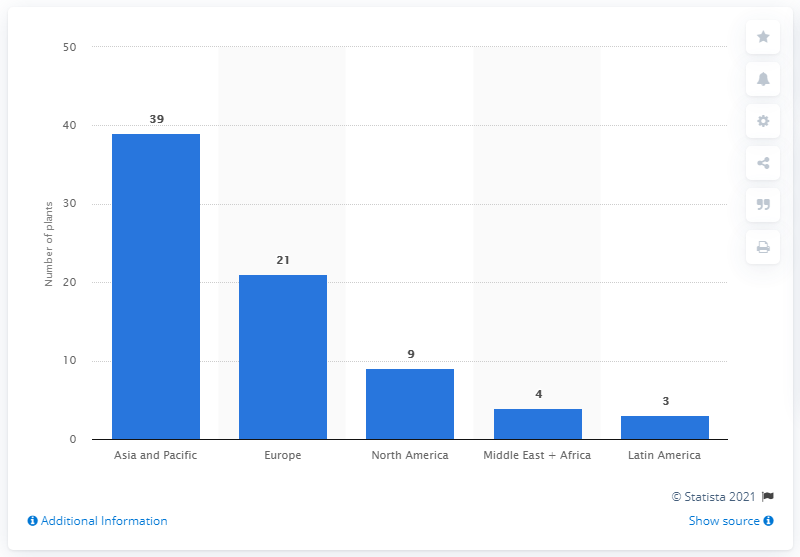Mention a couple of crucial points in this snapshot. In 2018, there were 21 plasma fractionation plants operating in Europe. In 2018, there were 39 plasma fractionation plants operating in the Asia-Pacific region. 